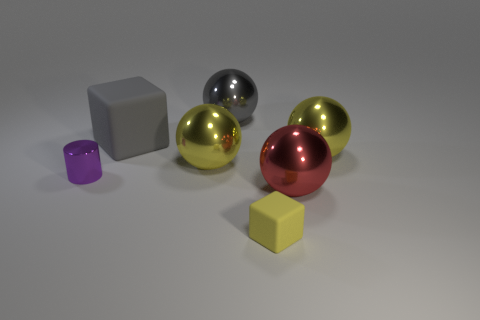Are there more small objects in front of the tiny yellow thing than gray metal balls?
Your answer should be very brief. No. Is the large rubber cube the same color as the small rubber block?
Make the answer very short. No. How many other big rubber objects have the same shape as the big red thing?
Make the answer very short. 0. There is a gray sphere that is the same material as the purple cylinder; what size is it?
Provide a succinct answer. Large. The thing that is both in front of the purple cylinder and behind the small block is what color?
Give a very brief answer. Red. What number of other gray things have the same size as the gray shiny object?
Keep it short and to the point. 1. There is a ball that is the same color as the large matte object; what is its size?
Keep it short and to the point. Large. What size is the ball that is both on the left side of the tiny yellow thing and in front of the big gray matte cube?
Give a very brief answer. Large. How many rubber cubes are on the left side of the matte object that is behind the matte object in front of the gray matte thing?
Make the answer very short. 0. Are there any big rubber objects that have the same color as the big cube?
Provide a short and direct response. No. 